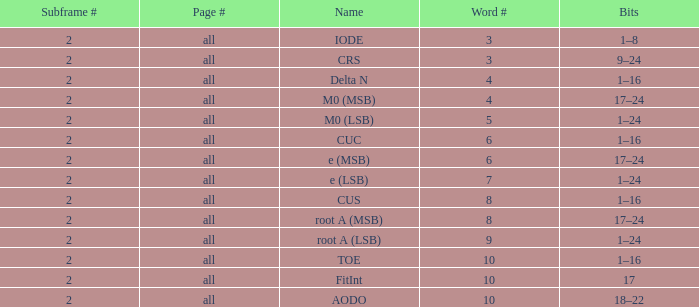What is the sum of subframes containing 18-22 bits? 2.0. 